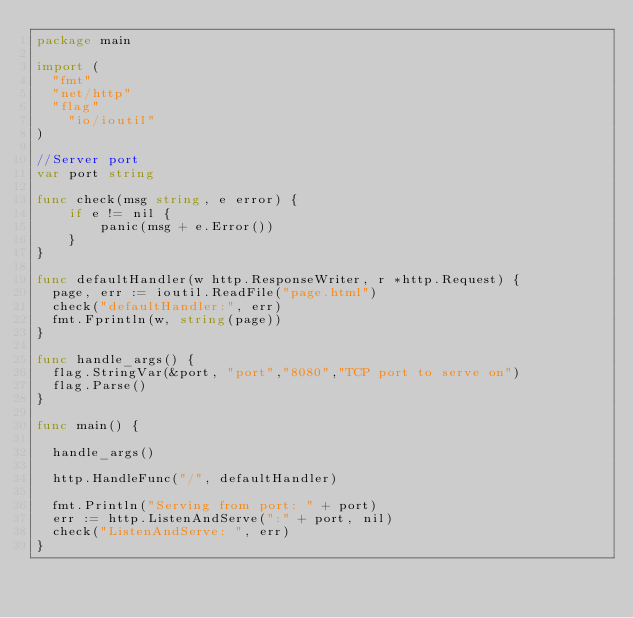<code> <loc_0><loc_0><loc_500><loc_500><_Go_>package main

import (
	"fmt"
	"net/http"
	"flag"
    "io/ioutil"
)

//Server port
var port string

func check(msg string, e error) {
    if e != nil {
        panic(msg + e.Error())
    }
}

func defaultHandler(w http.ResponseWriter, r *http.Request) {
	page, err := ioutil.ReadFile("page.html")
	check("defaultHandler:", err)
	fmt.Fprintln(w, string(page))
}

func handle_args() {
	flag.StringVar(&port, "port","8080","TCP port to serve on")
	flag.Parse()
}

func main() {

	handle_args()

	http.HandleFunc("/", defaultHandler)

	fmt.Println("Serving from port: " + port)
	err := http.ListenAndServe(":" + port, nil)
	check("ListenAndServe: ", err)
}
</code> 